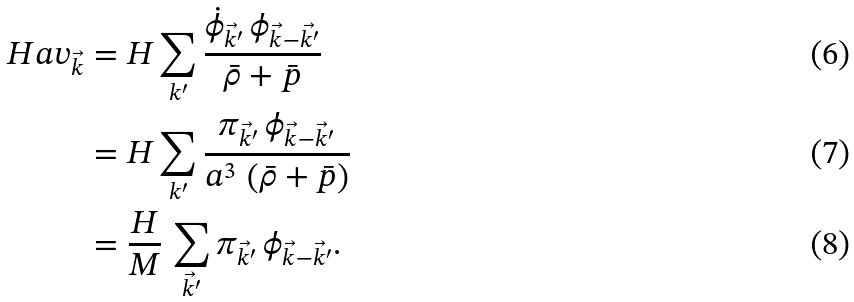<formula> <loc_0><loc_0><loc_500><loc_500>H a v _ { \vec { k } } & = H \sum _ { k ^ { \prime } } \frac { \dot { \phi } _ { \vec { k } ^ { \prime } } \, \phi _ { \vec { k } - \vec { k ^ { \prime } } } } { \bar { \rho } + \bar { p } } \\ & = H \sum _ { k ^ { \prime } } \frac { \pi _ { \vec { k } ^ { \prime } } \, \phi _ { \vec { k } - \vec { k } ^ { \prime } } } { a ^ { 3 } \, \left ( \bar { \rho } + \bar { p } \right ) } \\ & = \frac { H } { M } \, \sum _ { \vec { k } ^ { \prime } } \pi _ { \vec { k } ^ { \prime } } \, \phi _ { \vec { k } - \vec { k } ^ { \prime } } .</formula> 